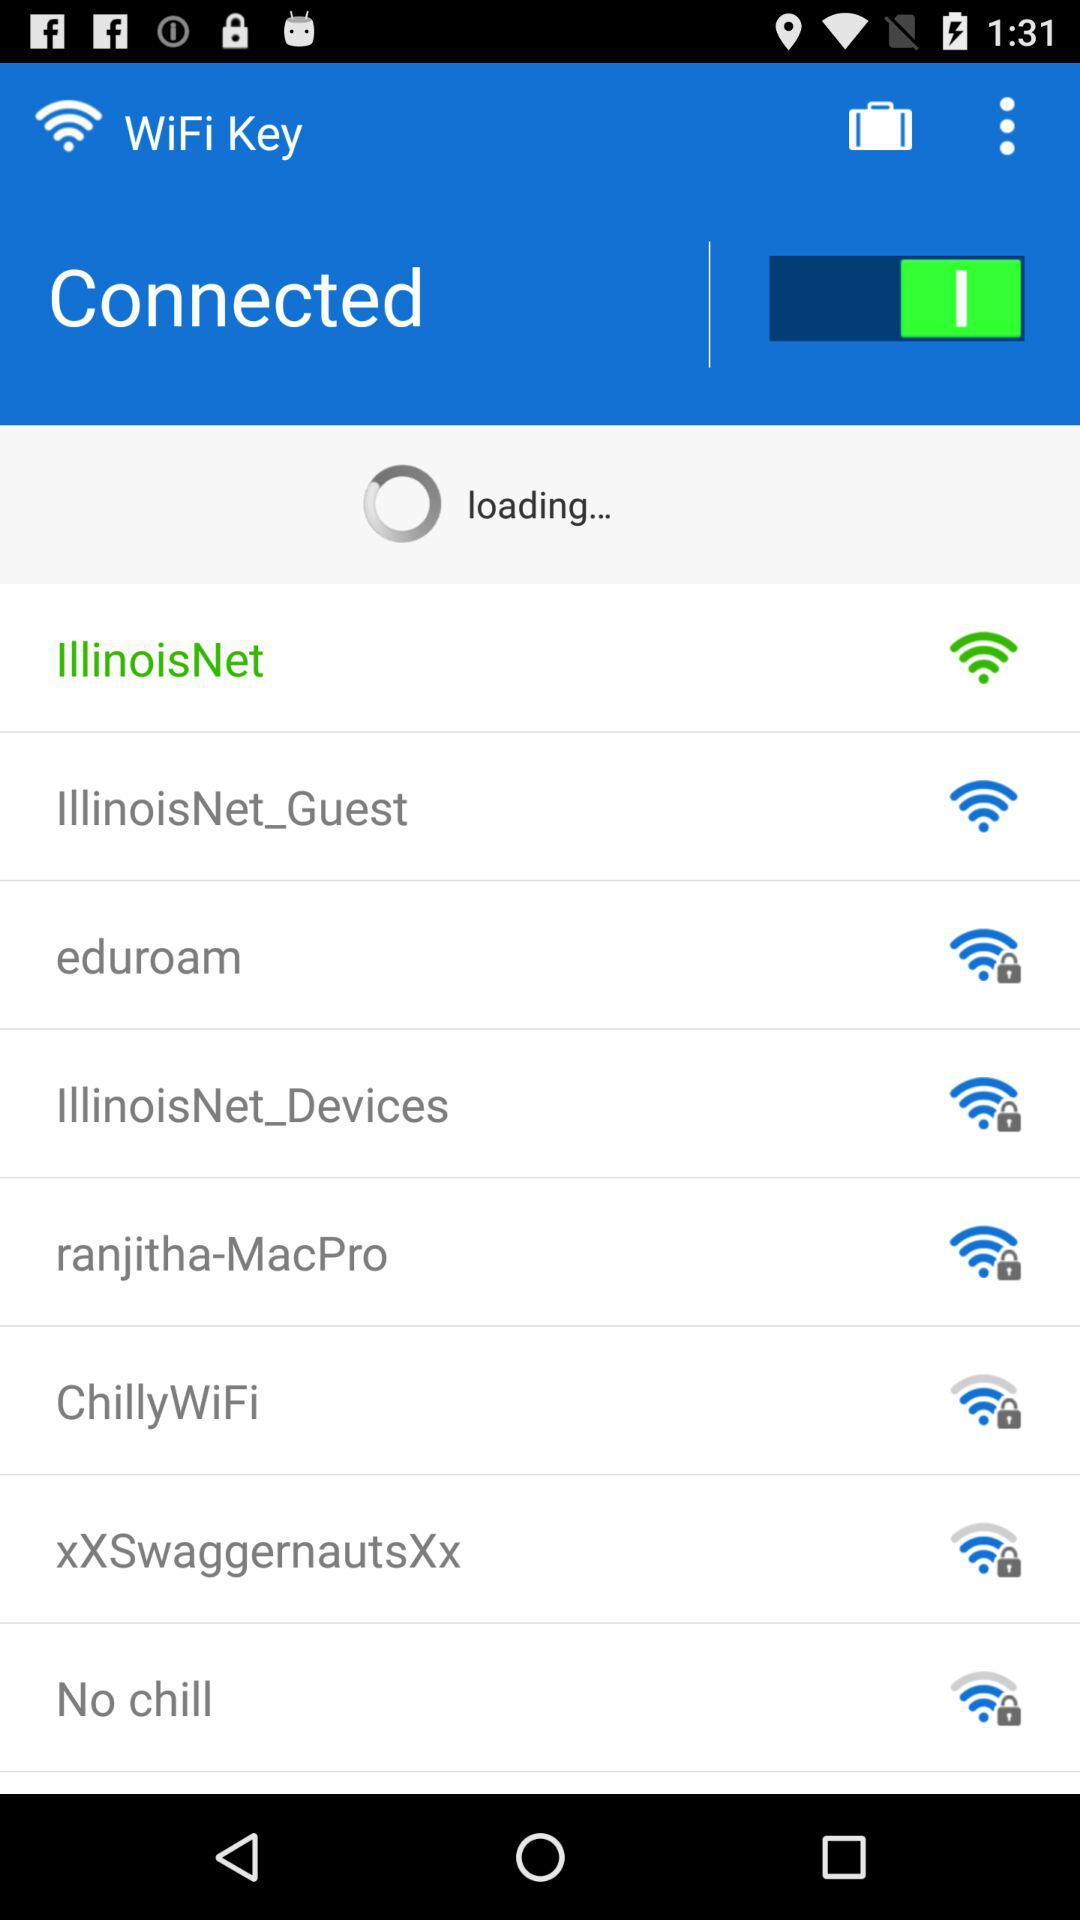Is "WiFi Key" button on of off? "WiFi Key" button is on. 